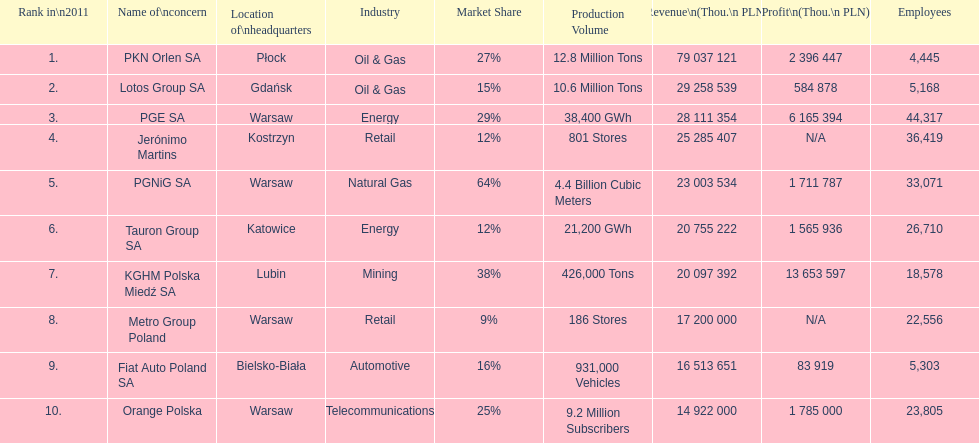Which company had the most employees? PGE SA. 